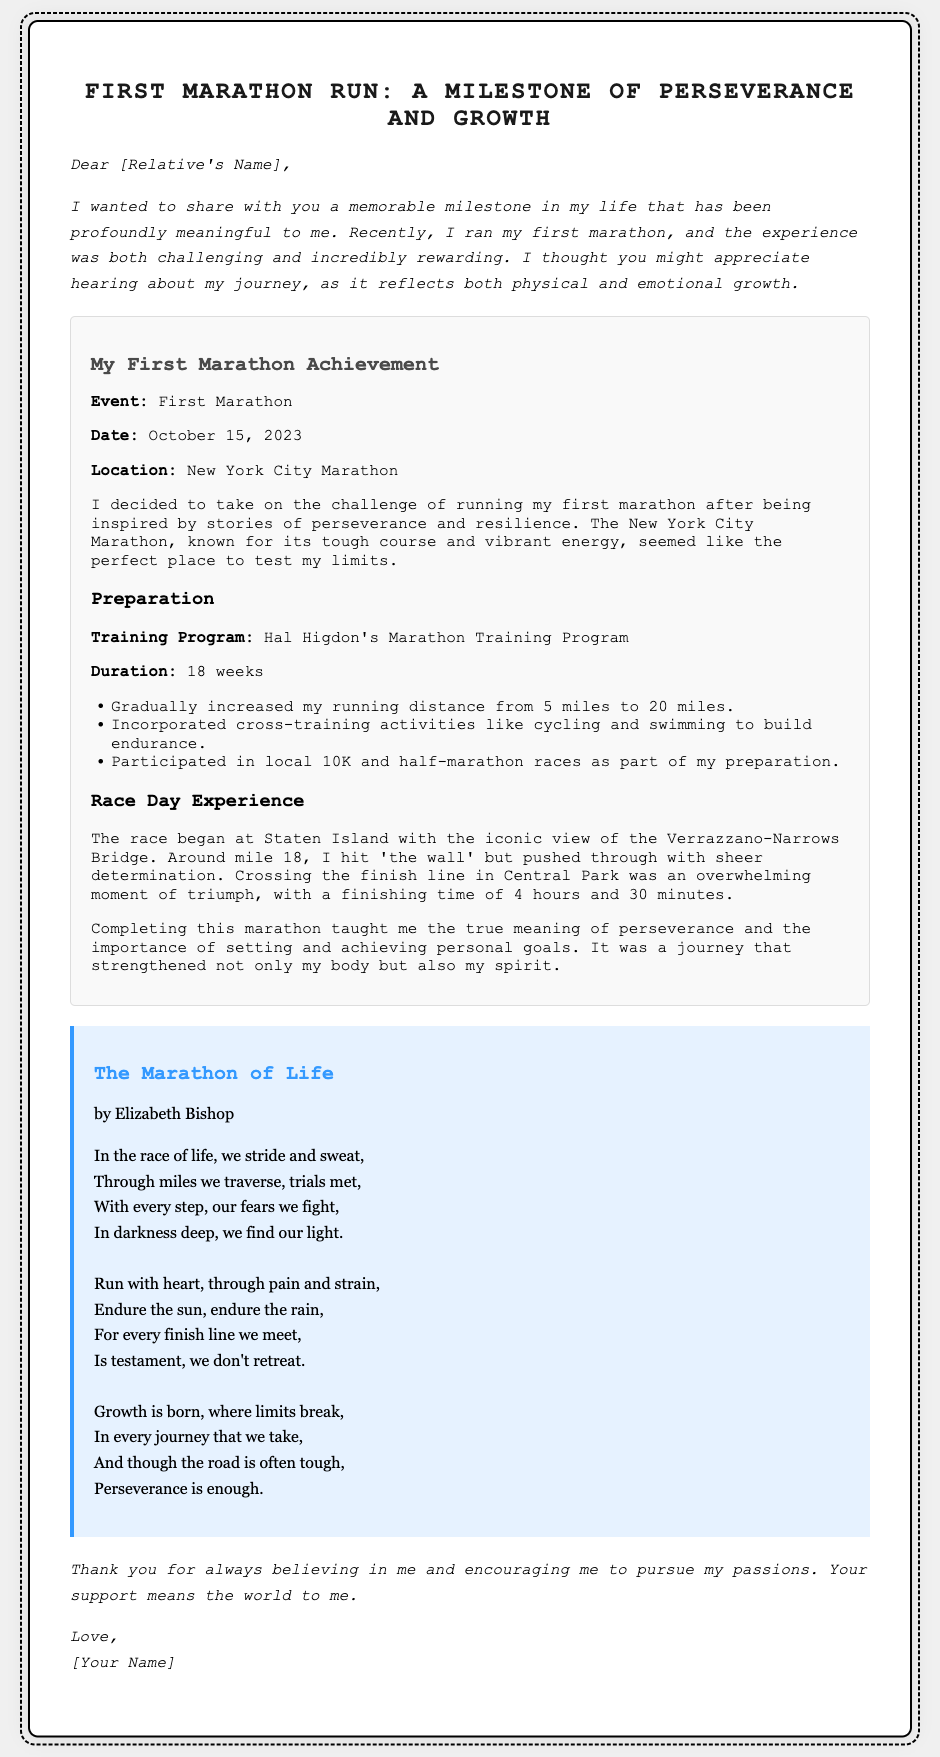What is the event discussed in the document? The document describes a milestone event, which is the first marathon run.
Answer: First Marathon When did the marathon take place? The document specifies the date when the first marathon occurred as October 15, 2023.
Answer: October 15, 2023 Where was the marathon located? The document indicates that the location of the marathon was New York City.
Answer: New York City What training program did the author follow? The author mentions using Hal Higdon's Marathon Training Program for their preparation.
Answer: Hal Higdon's Marathon Training Program What was the finishing time for the marathon? The document reveals that the author's finishing time was 4 hours and 30 minutes.
Answer: 4 hours and 30 minutes Which iconic bridge was mentioned at the start of the race? The document specifically names the Verrazzano-Narrows Bridge as an iconic view during the race start.
Answer: Verrazzano-Narrows Bridge What did the author experience around mile 18? The author describes hitting 'the wall' around mile 18 during the marathon.
Answer: 'the wall' What does the poem in the document encourage runners to do? The poem emphasizes enduring through challenges and showcases the importance of perseverance in the race of life.
Answer: Perseverance How long was the training program duration? The document states that the training program lasted for 18 weeks.
Answer: 18 weeks 